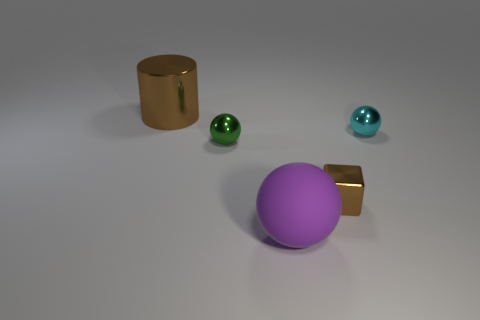Add 1 green metal balls. How many objects exist? 6 Subtract all cylinders. How many objects are left? 4 Add 3 cyan metal things. How many cyan metal things exist? 4 Subtract 0 blue spheres. How many objects are left? 5 Subtract all big shiny things. Subtract all tiny shiny cubes. How many objects are left? 3 Add 2 big cylinders. How many big cylinders are left? 3 